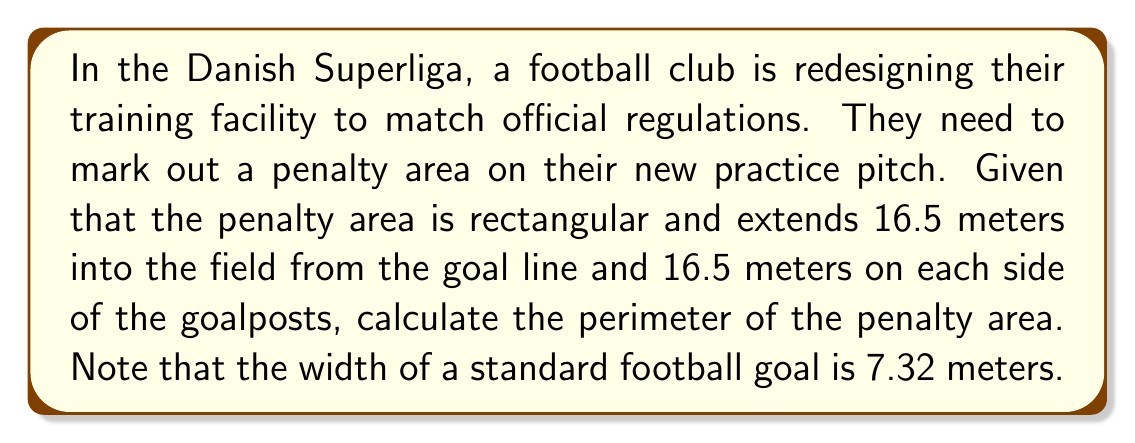Give your solution to this math problem. Let's approach this step-by-step:

1) First, we need to determine the width of the penalty area:
   - The penalty area extends 16.5 meters on each side of the goalposts
   - The width of the goal is 7.32 meters
   - So, the total width is: $16.5 + 7.32 + 16.5 = 40.32$ meters

2) We know the depth of the penalty area is 16.5 meters

3) Now we can visualize the penalty area as a rectangle:

[asy]
unitsize(1cm);
draw((0,0)--(40.32,0)--(40.32,16.5)--(0,16.5)--cycle);
label("40.32 m", (20.16,0), S);
label("16.5 m", (0,8.25), W);
[/asy]

4) To calculate the perimeter, we use the formula for the perimeter of a rectangle:
   $$P = 2l + 2w$$
   Where $P$ is the perimeter, $l$ is the length (width in this case), and $w$ is the width (depth in this case)

5) Substituting our values:
   $$P = 2(40.32) + 2(16.5)$$

6) Calculating:
   $$P = 80.64 + 33 = 113.64$$

Therefore, the perimeter of the penalty area is 113.64 meters.
Answer: $113.64$ meters 